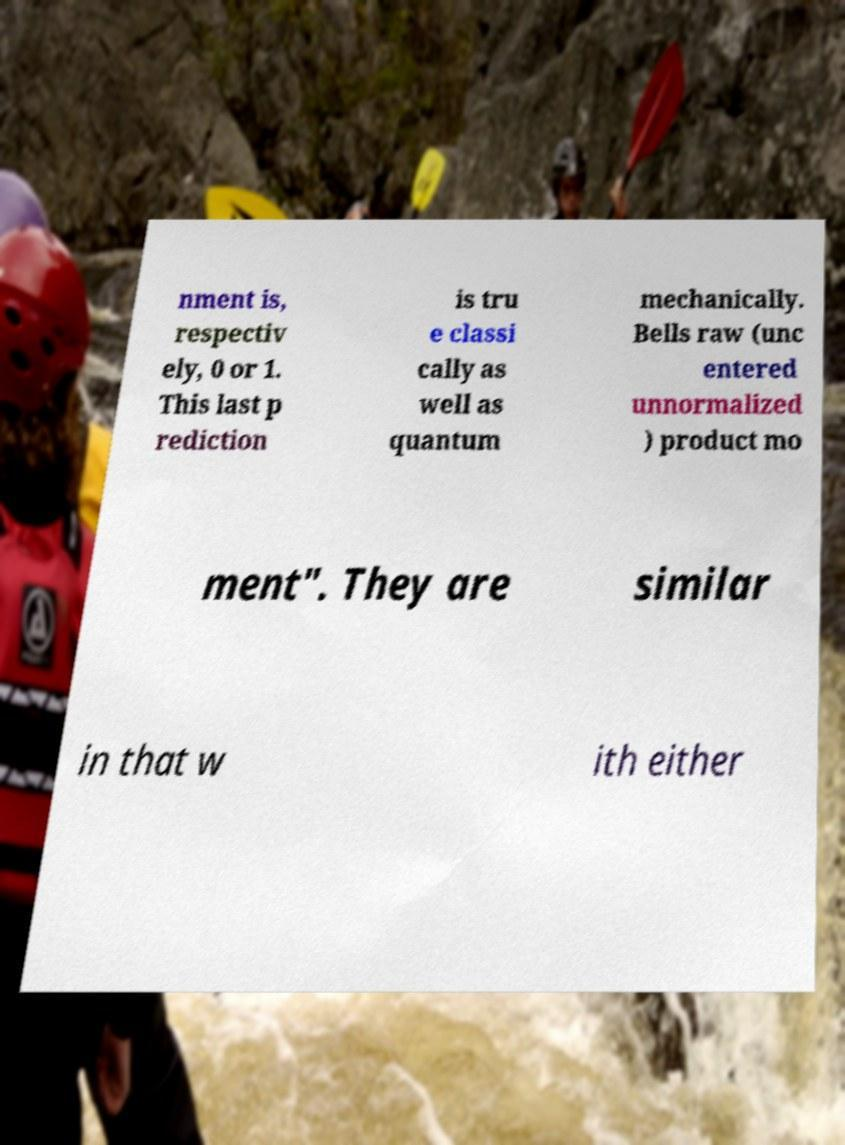Could you extract and type out the text from this image? nment is, respectiv ely, 0 or 1. This last p rediction is tru e classi cally as well as quantum mechanically. Bells raw (unc entered unnormalized ) product mo ment". They are similar in that w ith either 